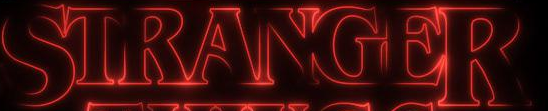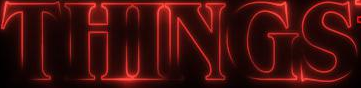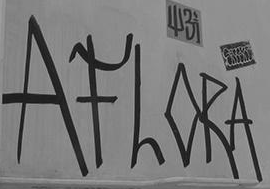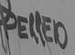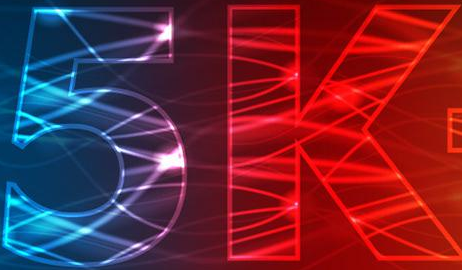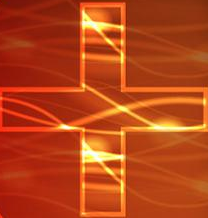What text appears in these images from left to right, separated by a semicolon? STRANGER; THINGS; AFLORA; PELLED; 5k; + 